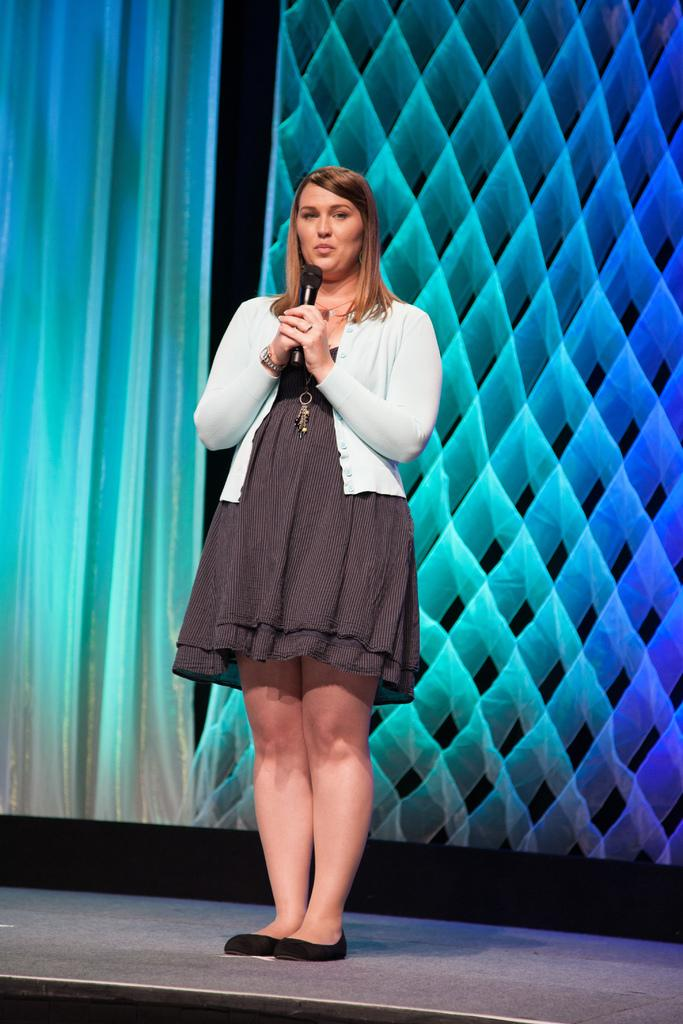What is the person in the image doing? The person is holding a microphone in the image. What is the person's posture in the image? The person is standing in the image. What can be seen beneath the person's feet in the image? There is ground visible in the image. What is visible in the background of the image? There is a wall with a design in the background of the image. How many snakes are crawling on the person's arm in the image? There are no snakes present in the image; the person is holding a microphone. What type of pencil can be seen in the person's hand in the image? There is no pencil visible in the person's hand in the image; they are holding a microphone. 